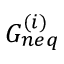Convert formula to latex. <formula><loc_0><loc_0><loc_500><loc_500>G _ { n e q } ^ { ( i ) }</formula> 